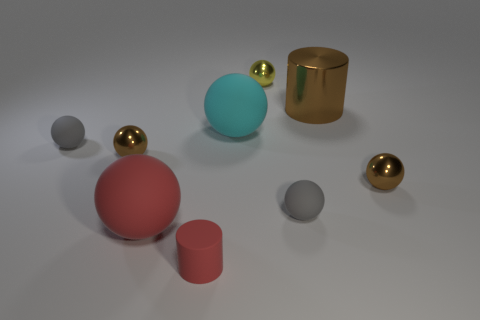What color is the small sphere that is to the right of the large brown cylinder?
Your answer should be very brief. Brown. What material is the brown thing that is both right of the rubber cylinder and in front of the large cyan object?
Provide a short and direct response. Metal. There is a big red thing that is made of the same material as the small red object; what shape is it?
Provide a short and direct response. Sphere. There is a thing behind the big cylinder; what number of brown balls are to the left of it?
Make the answer very short. 1. What number of brown shiny spheres are to the left of the cyan rubber ball and to the right of the cyan matte thing?
Your answer should be compact. 0. What number of other things are the same material as the cyan sphere?
Offer a terse response. 4. What is the color of the tiny shiny sphere that is behind the tiny matte object on the left side of the red cylinder?
Provide a short and direct response. Yellow. There is a tiny rubber sphere that is left of the big cyan matte object; does it have the same color as the shiny cylinder?
Provide a succinct answer. No. Is the size of the red ball the same as the cyan ball?
Offer a terse response. Yes. There is a red matte thing that is the same size as the yellow shiny object; what is its shape?
Your answer should be compact. Cylinder. 